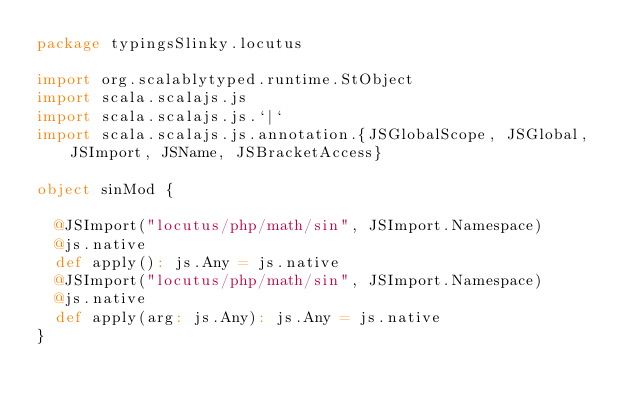<code> <loc_0><loc_0><loc_500><loc_500><_Scala_>package typingsSlinky.locutus

import org.scalablytyped.runtime.StObject
import scala.scalajs.js
import scala.scalajs.js.`|`
import scala.scalajs.js.annotation.{JSGlobalScope, JSGlobal, JSImport, JSName, JSBracketAccess}

object sinMod {
  
  @JSImport("locutus/php/math/sin", JSImport.Namespace)
  @js.native
  def apply(): js.Any = js.native
  @JSImport("locutus/php/math/sin", JSImport.Namespace)
  @js.native
  def apply(arg: js.Any): js.Any = js.native
}
</code> 